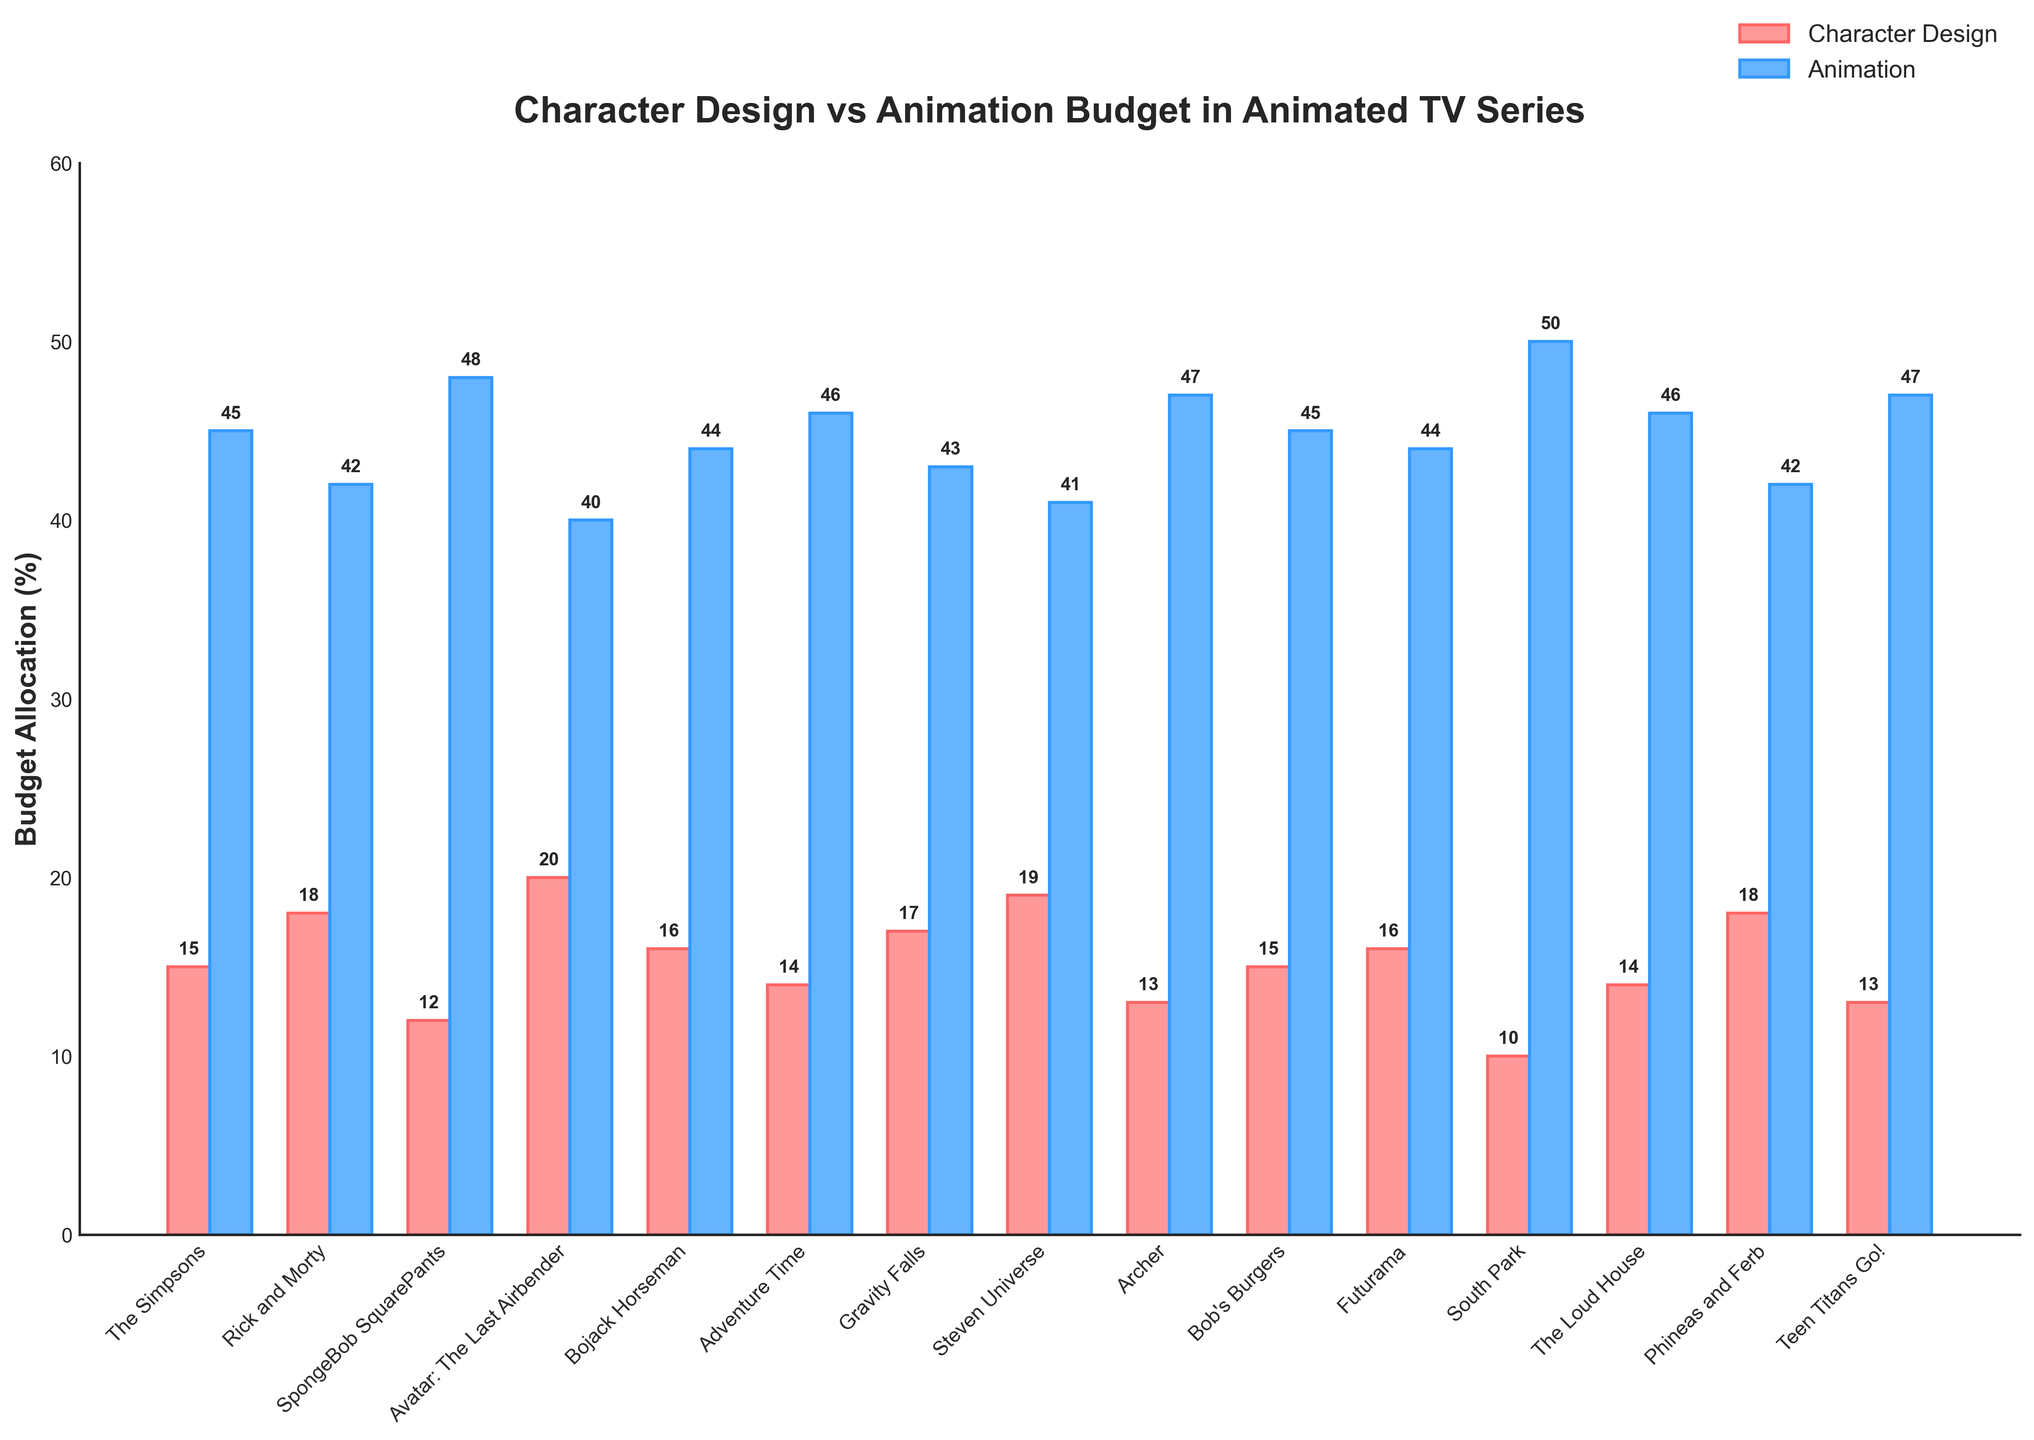What's the average budget allocation for character design across all series? To find the average, sum all the character design budget percentages and divide by the number of series. (15 + 18 + 12 + 20 + 16 + 14 + 17 + 19 + 13 + 15 + 16 + 10 + 14 + 18 + 13) = 220, then divide by 15 (number of series), 220/15 = 14.67.
Answer: 14.67 Which series has the highest budget allocation for animation? Look at the highest bar in the animation category (blue bars). South Park has the highest animation budget of 50%.
Answer: South Park Compare the budget allocations for character design in 'Avatar: The Last Airbender' and 'Steven Universe': which is higher and by how much? Compare the character design budget: 'Avatar: The Last Airbender' has 20%, 'Steven Universe' has 19%. 20% is higher, and the difference is 20 - 19 = 1%.
Answer: Avatar: The Last Airbender by 1% What is the difference in budget allocations for animation between 'Bojack Horseman' and 'Adventure Time'? Compare the animation budget: 'Bojack Horseman' has 44%, 'Adventure Time' has 46%. Difference = 46 - 44 = 2%.
Answer: 2% How much more budget does 'Teen Titans Go!' allocate to animation compared to character design? Look at 'Teen Titans Go!': Character Design = 13%, Animation = 47%. Difference = 47 - 13 = 34%.
Answer: 34% Which series has the smallest difference between character design and animation budget? Calculate the difference for each series and find the smallest: The Simpsons (30%), Rick and Morty (24%), SpongeBob SquarePants (36%), Avatar: The Last Airbender (20%), Bojack Horseman (28%), Adventure Time (32%), Gravity Falls (26%), Steven Universe (22%), Archer (34%), Bob's Burgers (30%), Futurama (28%), South Park (40%), The Loud House (32%), Phineas and Ferb (24%), Teen Titans Go! (34%). The smallest difference is Avatar: The Last Airbender (20%).
Answer: Avatar: The Last Airbender In terms of character design, which series allocates the same budget as 'Bob's Burgers'? Check the character design budget for 'Bob's Burgers' which is 15%, and look for other series with the same percentage: 'The Simpsons'.
Answer: The Simpsons What is the total percentage of budget allocation for animation across all series? Sum the animation budget percentages: (45 + 42 + 48 + 40 + 44 + 46 + 43 + 41 + 47 + 45 + 44 + 50 + 46 + 42 + 47) = 670%.
Answer: 670% Is there any series that allocates more than 20% to character design? Look at the character design percentages: All values are 20% or less.
Answer: No Among 'Rick and Morty', 'Gravity Falls,' and 'Archer', which series has the highest character design budget allocation? Compare character design budgets: 'Rick and Morty' (18%), 'Gravity Falls' (17%), 'Archer' (13%). 'Rick and Morty' has the highest.
Answer: Rick and Morty 